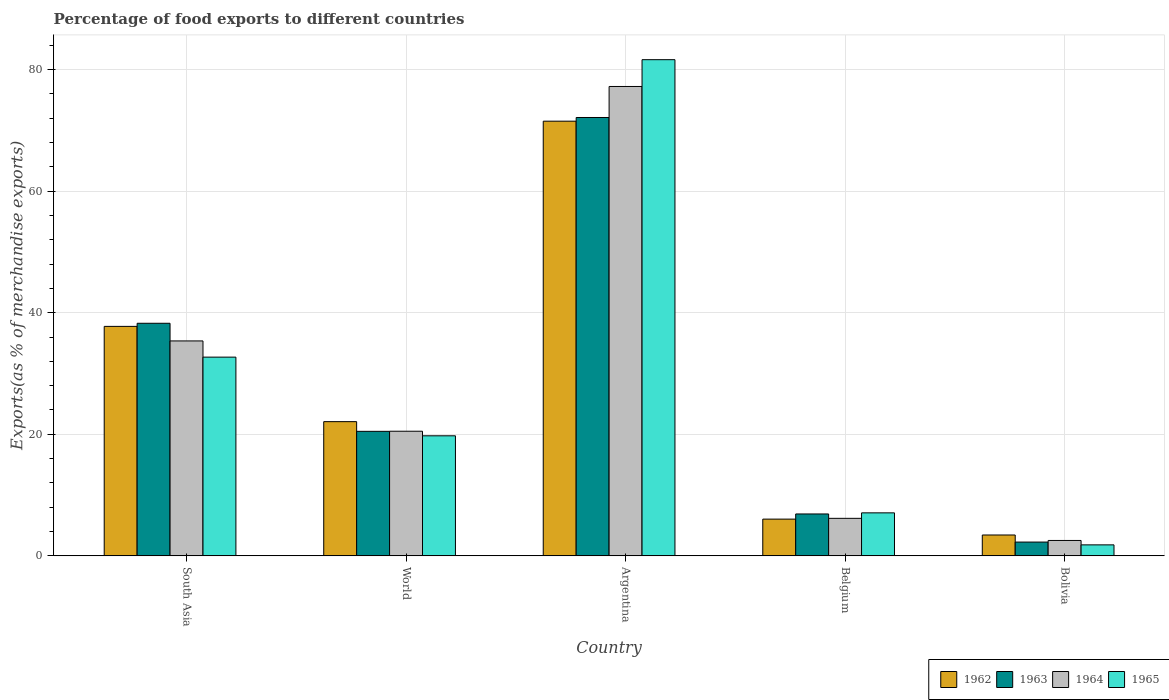Are the number of bars per tick equal to the number of legend labels?
Give a very brief answer. Yes. How many bars are there on the 4th tick from the left?
Ensure brevity in your answer.  4. How many bars are there on the 2nd tick from the right?
Your answer should be compact. 4. In how many cases, is the number of bars for a given country not equal to the number of legend labels?
Offer a terse response. 0. What is the percentage of exports to different countries in 1962 in Bolivia?
Ensure brevity in your answer.  3.43. Across all countries, what is the maximum percentage of exports to different countries in 1965?
Offer a terse response. 81.64. Across all countries, what is the minimum percentage of exports to different countries in 1964?
Offer a very short reply. 2.53. In which country was the percentage of exports to different countries in 1964 maximum?
Ensure brevity in your answer.  Argentina. What is the total percentage of exports to different countries in 1963 in the graph?
Your answer should be very brief. 140.03. What is the difference between the percentage of exports to different countries in 1963 in South Asia and that in World?
Make the answer very short. 17.78. What is the difference between the percentage of exports to different countries in 1962 in South Asia and the percentage of exports to different countries in 1965 in Argentina?
Offer a terse response. -43.88. What is the average percentage of exports to different countries in 1965 per country?
Provide a succinct answer. 28.59. What is the difference between the percentage of exports to different countries of/in 1965 and percentage of exports to different countries of/in 1964 in Bolivia?
Give a very brief answer. -0.73. What is the ratio of the percentage of exports to different countries in 1962 in Argentina to that in Bolivia?
Your answer should be very brief. 20.86. What is the difference between the highest and the second highest percentage of exports to different countries in 1965?
Your response must be concise. -48.94. What is the difference between the highest and the lowest percentage of exports to different countries in 1962?
Your answer should be very brief. 68.09. In how many countries, is the percentage of exports to different countries in 1963 greater than the average percentage of exports to different countries in 1963 taken over all countries?
Your response must be concise. 2. What does the 3rd bar from the right in South Asia represents?
Ensure brevity in your answer.  1963. Is it the case that in every country, the sum of the percentage of exports to different countries in 1964 and percentage of exports to different countries in 1963 is greater than the percentage of exports to different countries in 1962?
Your response must be concise. Yes. Are all the bars in the graph horizontal?
Your answer should be very brief. No. How many countries are there in the graph?
Your answer should be very brief. 5. Where does the legend appear in the graph?
Make the answer very short. Bottom right. How are the legend labels stacked?
Keep it short and to the point. Horizontal. What is the title of the graph?
Keep it short and to the point. Percentage of food exports to different countries. What is the label or title of the Y-axis?
Your response must be concise. Exports(as % of merchandise exports). What is the Exports(as % of merchandise exports) in 1962 in South Asia?
Your answer should be very brief. 37.75. What is the Exports(as % of merchandise exports) in 1963 in South Asia?
Your answer should be compact. 38.26. What is the Exports(as % of merchandise exports) of 1964 in South Asia?
Your answer should be very brief. 35.36. What is the Exports(as % of merchandise exports) of 1965 in South Asia?
Your response must be concise. 32.7. What is the Exports(as % of merchandise exports) in 1962 in World?
Ensure brevity in your answer.  22.08. What is the Exports(as % of merchandise exports) of 1963 in World?
Make the answer very short. 20.49. What is the Exports(as % of merchandise exports) of 1964 in World?
Keep it short and to the point. 20.5. What is the Exports(as % of merchandise exports) in 1965 in World?
Offer a terse response. 19.75. What is the Exports(as % of merchandise exports) in 1962 in Argentina?
Your answer should be very brief. 71.52. What is the Exports(as % of merchandise exports) of 1963 in Argentina?
Give a very brief answer. 72.12. What is the Exports(as % of merchandise exports) in 1964 in Argentina?
Your answer should be compact. 77.23. What is the Exports(as % of merchandise exports) of 1965 in Argentina?
Your answer should be compact. 81.64. What is the Exports(as % of merchandise exports) of 1962 in Belgium?
Give a very brief answer. 6.04. What is the Exports(as % of merchandise exports) of 1963 in Belgium?
Provide a succinct answer. 6.89. What is the Exports(as % of merchandise exports) of 1964 in Belgium?
Your answer should be compact. 6.17. What is the Exports(as % of merchandise exports) in 1965 in Belgium?
Your response must be concise. 7.07. What is the Exports(as % of merchandise exports) in 1962 in Bolivia?
Provide a succinct answer. 3.43. What is the Exports(as % of merchandise exports) of 1963 in Bolivia?
Offer a terse response. 2.27. What is the Exports(as % of merchandise exports) in 1964 in Bolivia?
Your answer should be very brief. 2.53. What is the Exports(as % of merchandise exports) of 1965 in Bolivia?
Offer a terse response. 1.81. Across all countries, what is the maximum Exports(as % of merchandise exports) in 1962?
Keep it short and to the point. 71.52. Across all countries, what is the maximum Exports(as % of merchandise exports) of 1963?
Make the answer very short. 72.12. Across all countries, what is the maximum Exports(as % of merchandise exports) in 1964?
Provide a short and direct response. 77.23. Across all countries, what is the maximum Exports(as % of merchandise exports) of 1965?
Your answer should be very brief. 81.64. Across all countries, what is the minimum Exports(as % of merchandise exports) in 1962?
Offer a terse response. 3.43. Across all countries, what is the minimum Exports(as % of merchandise exports) in 1963?
Make the answer very short. 2.27. Across all countries, what is the minimum Exports(as % of merchandise exports) in 1964?
Provide a short and direct response. 2.53. Across all countries, what is the minimum Exports(as % of merchandise exports) in 1965?
Offer a terse response. 1.81. What is the total Exports(as % of merchandise exports) of 1962 in the graph?
Keep it short and to the point. 140.82. What is the total Exports(as % of merchandise exports) in 1963 in the graph?
Ensure brevity in your answer.  140.03. What is the total Exports(as % of merchandise exports) of 1964 in the graph?
Your answer should be very brief. 141.79. What is the total Exports(as % of merchandise exports) in 1965 in the graph?
Offer a very short reply. 142.96. What is the difference between the Exports(as % of merchandise exports) of 1962 in South Asia and that in World?
Your answer should be very brief. 15.67. What is the difference between the Exports(as % of merchandise exports) of 1963 in South Asia and that in World?
Ensure brevity in your answer.  17.78. What is the difference between the Exports(as % of merchandise exports) in 1964 in South Asia and that in World?
Ensure brevity in your answer.  14.86. What is the difference between the Exports(as % of merchandise exports) in 1965 in South Asia and that in World?
Provide a succinct answer. 12.95. What is the difference between the Exports(as % of merchandise exports) of 1962 in South Asia and that in Argentina?
Offer a terse response. -33.76. What is the difference between the Exports(as % of merchandise exports) in 1963 in South Asia and that in Argentina?
Give a very brief answer. -33.86. What is the difference between the Exports(as % of merchandise exports) in 1964 in South Asia and that in Argentina?
Your response must be concise. -41.87. What is the difference between the Exports(as % of merchandise exports) in 1965 in South Asia and that in Argentina?
Keep it short and to the point. -48.94. What is the difference between the Exports(as % of merchandise exports) in 1962 in South Asia and that in Belgium?
Provide a succinct answer. 31.71. What is the difference between the Exports(as % of merchandise exports) in 1963 in South Asia and that in Belgium?
Offer a terse response. 31.37. What is the difference between the Exports(as % of merchandise exports) of 1964 in South Asia and that in Belgium?
Offer a terse response. 29.19. What is the difference between the Exports(as % of merchandise exports) of 1965 in South Asia and that in Belgium?
Give a very brief answer. 25.62. What is the difference between the Exports(as % of merchandise exports) in 1962 in South Asia and that in Bolivia?
Provide a succinct answer. 34.32. What is the difference between the Exports(as % of merchandise exports) in 1963 in South Asia and that in Bolivia?
Offer a very short reply. 36. What is the difference between the Exports(as % of merchandise exports) in 1964 in South Asia and that in Bolivia?
Your answer should be very brief. 32.83. What is the difference between the Exports(as % of merchandise exports) in 1965 in South Asia and that in Bolivia?
Your answer should be very brief. 30.89. What is the difference between the Exports(as % of merchandise exports) in 1962 in World and that in Argentina?
Provide a short and direct response. -49.44. What is the difference between the Exports(as % of merchandise exports) in 1963 in World and that in Argentina?
Offer a very short reply. -51.64. What is the difference between the Exports(as % of merchandise exports) of 1964 in World and that in Argentina?
Keep it short and to the point. -56.72. What is the difference between the Exports(as % of merchandise exports) of 1965 in World and that in Argentina?
Your answer should be very brief. -61.88. What is the difference between the Exports(as % of merchandise exports) in 1962 in World and that in Belgium?
Provide a succinct answer. 16.04. What is the difference between the Exports(as % of merchandise exports) of 1963 in World and that in Belgium?
Provide a succinct answer. 13.6. What is the difference between the Exports(as % of merchandise exports) in 1964 in World and that in Belgium?
Make the answer very short. 14.33. What is the difference between the Exports(as % of merchandise exports) in 1965 in World and that in Belgium?
Offer a very short reply. 12.68. What is the difference between the Exports(as % of merchandise exports) in 1962 in World and that in Bolivia?
Make the answer very short. 18.65. What is the difference between the Exports(as % of merchandise exports) of 1963 in World and that in Bolivia?
Provide a short and direct response. 18.22. What is the difference between the Exports(as % of merchandise exports) of 1964 in World and that in Bolivia?
Give a very brief answer. 17.97. What is the difference between the Exports(as % of merchandise exports) in 1965 in World and that in Bolivia?
Your answer should be compact. 17.94. What is the difference between the Exports(as % of merchandise exports) in 1962 in Argentina and that in Belgium?
Make the answer very short. 65.47. What is the difference between the Exports(as % of merchandise exports) of 1963 in Argentina and that in Belgium?
Provide a short and direct response. 65.23. What is the difference between the Exports(as % of merchandise exports) of 1964 in Argentina and that in Belgium?
Your response must be concise. 71.06. What is the difference between the Exports(as % of merchandise exports) in 1965 in Argentina and that in Belgium?
Your answer should be very brief. 74.56. What is the difference between the Exports(as % of merchandise exports) in 1962 in Argentina and that in Bolivia?
Ensure brevity in your answer.  68.09. What is the difference between the Exports(as % of merchandise exports) of 1963 in Argentina and that in Bolivia?
Make the answer very short. 69.86. What is the difference between the Exports(as % of merchandise exports) of 1964 in Argentina and that in Bolivia?
Your answer should be compact. 74.69. What is the difference between the Exports(as % of merchandise exports) in 1965 in Argentina and that in Bolivia?
Ensure brevity in your answer.  79.83. What is the difference between the Exports(as % of merchandise exports) in 1962 in Belgium and that in Bolivia?
Make the answer very short. 2.61. What is the difference between the Exports(as % of merchandise exports) in 1963 in Belgium and that in Bolivia?
Your response must be concise. 4.62. What is the difference between the Exports(as % of merchandise exports) of 1964 in Belgium and that in Bolivia?
Provide a short and direct response. 3.64. What is the difference between the Exports(as % of merchandise exports) of 1965 in Belgium and that in Bolivia?
Provide a succinct answer. 5.27. What is the difference between the Exports(as % of merchandise exports) in 1962 in South Asia and the Exports(as % of merchandise exports) in 1963 in World?
Offer a terse response. 17.27. What is the difference between the Exports(as % of merchandise exports) in 1962 in South Asia and the Exports(as % of merchandise exports) in 1964 in World?
Provide a short and direct response. 17.25. What is the difference between the Exports(as % of merchandise exports) in 1962 in South Asia and the Exports(as % of merchandise exports) in 1965 in World?
Ensure brevity in your answer.  18. What is the difference between the Exports(as % of merchandise exports) of 1963 in South Asia and the Exports(as % of merchandise exports) of 1964 in World?
Keep it short and to the point. 17.76. What is the difference between the Exports(as % of merchandise exports) in 1963 in South Asia and the Exports(as % of merchandise exports) in 1965 in World?
Your response must be concise. 18.51. What is the difference between the Exports(as % of merchandise exports) in 1964 in South Asia and the Exports(as % of merchandise exports) in 1965 in World?
Give a very brief answer. 15.61. What is the difference between the Exports(as % of merchandise exports) of 1962 in South Asia and the Exports(as % of merchandise exports) of 1963 in Argentina?
Offer a very short reply. -34.37. What is the difference between the Exports(as % of merchandise exports) in 1962 in South Asia and the Exports(as % of merchandise exports) in 1964 in Argentina?
Ensure brevity in your answer.  -39.47. What is the difference between the Exports(as % of merchandise exports) in 1962 in South Asia and the Exports(as % of merchandise exports) in 1965 in Argentina?
Your response must be concise. -43.88. What is the difference between the Exports(as % of merchandise exports) of 1963 in South Asia and the Exports(as % of merchandise exports) of 1964 in Argentina?
Make the answer very short. -38.96. What is the difference between the Exports(as % of merchandise exports) of 1963 in South Asia and the Exports(as % of merchandise exports) of 1965 in Argentina?
Provide a short and direct response. -43.37. What is the difference between the Exports(as % of merchandise exports) of 1964 in South Asia and the Exports(as % of merchandise exports) of 1965 in Argentina?
Your answer should be compact. -46.28. What is the difference between the Exports(as % of merchandise exports) of 1962 in South Asia and the Exports(as % of merchandise exports) of 1963 in Belgium?
Provide a short and direct response. 30.86. What is the difference between the Exports(as % of merchandise exports) in 1962 in South Asia and the Exports(as % of merchandise exports) in 1964 in Belgium?
Your answer should be very brief. 31.58. What is the difference between the Exports(as % of merchandise exports) in 1962 in South Asia and the Exports(as % of merchandise exports) in 1965 in Belgium?
Provide a succinct answer. 30.68. What is the difference between the Exports(as % of merchandise exports) in 1963 in South Asia and the Exports(as % of merchandise exports) in 1964 in Belgium?
Offer a very short reply. 32.09. What is the difference between the Exports(as % of merchandise exports) in 1963 in South Asia and the Exports(as % of merchandise exports) in 1965 in Belgium?
Your answer should be very brief. 31.19. What is the difference between the Exports(as % of merchandise exports) in 1964 in South Asia and the Exports(as % of merchandise exports) in 1965 in Belgium?
Offer a terse response. 28.29. What is the difference between the Exports(as % of merchandise exports) of 1962 in South Asia and the Exports(as % of merchandise exports) of 1963 in Bolivia?
Offer a terse response. 35.49. What is the difference between the Exports(as % of merchandise exports) in 1962 in South Asia and the Exports(as % of merchandise exports) in 1964 in Bolivia?
Offer a very short reply. 35.22. What is the difference between the Exports(as % of merchandise exports) in 1962 in South Asia and the Exports(as % of merchandise exports) in 1965 in Bolivia?
Ensure brevity in your answer.  35.95. What is the difference between the Exports(as % of merchandise exports) of 1963 in South Asia and the Exports(as % of merchandise exports) of 1964 in Bolivia?
Provide a succinct answer. 35.73. What is the difference between the Exports(as % of merchandise exports) of 1963 in South Asia and the Exports(as % of merchandise exports) of 1965 in Bolivia?
Keep it short and to the point. 36.46. What is the difference between the Exports(as % of merchandise exports) in 1964 in South Asia and the Exports(as % of merchandise exports) in 1965 in Bolivia?
Give a very brief answer. 33.55. What is the difference between the Exports(as % of merchandise exports) of 1962 in World and the Exports(as % of merchandise exports) of 1963 in Argentina?
Your answer should be very brief. -50.04. What is the difference between the Exports(as % of merchandise exports) in 1962 in World and the Exports(as % of merchandise exports) in 1964 in Argentina?
Give a very brief answer. -55.15. What is the difference between the Exports(as % of merchandise exports) in 1962 in World and the Exports(as % of merchandise exports) in 1965 in Argentina?
Keep it short and to the point. -59.55. What is the difference between the Exports(as % of merchandise exports) of 1963 in World and the Exports(as % of merchandise exports) of 1964 in Argentina?
Offer a terse response. -56.74. What is the difference between the Exports(as % of merchandise exports) of 1963 in World and the Exports(as % of merchandise exports) of 1965 in Argentina?
Your answer should be compact. -61.15. What is the difference between the Exports(as % of merchandise exports) in 1964 in World and the Exports(as % of merchandise exports) in 1965 in Argentina?
Provide a short and direct response. -61.13. What is the difference between the Exports(as % of merchandise exports) in 1962 in World and the Exports(as % of merchandise exports) in 1963 in Belgium?
Your answer should be very brief. 15.19. What is the difference between the Exports(as % of merchandise exports) in 1962 in World and the Exports(as % of merchandise exports) in 1964 in Belgium?
Provide a short and direct response. 15.91. What is the difference between the Exports(as % of merchandise exports) in 1962 in World and the Exports(as % of merchandise exports) in 1965 in Belgium?
Make the answer very short. 15.01. What is the difference between the Exports(as % of merchandise exports) of 1963 in World and the Exports(as % of merchandise exports) of 1964 in Belgium?
Give a very brief answer. 14.32. What is the difference between the Exports(as % of merchandise exports) of 1963 in World and the Exports(as % of merchandise exports) of 1965 in Belgium?
Make the answer very short. 13.41. What is the difference between the Exports(as % of merchandise exports) in 1964 in World and the Exports(as % of merchandise exports) in 1965 in Belgium?
Offer a terse response. 13.43. What is the difference between the Exports(as % of merchandise exports) of 1962 in World and the Exports(as % of merchandise exports) of 1963 in Bolivia?
Provide a short and direct response. 19.81. What is the difference between the Exports(as % of merchandise exports) in 1962 in World and the Exports(as % of merchandise exports) in 1964 in Bolivia?
Offer a very short reply. 19.55. What is the difference between the Exports(as % of merchandise exports) of 1962 in World and the Exports(as % of merchandise exports) of 1965 in Bolivia?
Ensure brevity in your answer.  20.27. What is the difference between the Exports(as % of merchandise exports) in 1963 in World and the Exports(as % of merchandise exports) in 1964 in Bolivia?
Ensure brevity in your answer.  17.95. What is the difference between the Exports(as % of merchandise exports) in 1963 in World and the Exports(as % of merchandise exports) in 1965 in Bolivia?
Your response must be concise. 18.68. What is the difference between the Exports(as % of merchandise exports) in 1964 in World and the Exports(as % of merchandise exports) in 1965 in Bolivia?
Your response must be concise. 18.7. What is the difference between the Exports(as % of merchandise exports) in 1962 in Argentina and the Exports(as % of merchandise exports) in 1963 in Belgium?
Ensure brevity in your answer.  64.63. What is the difference between the Exports(as % of merchandise exports) in 1962 in Argentina and the Exports(as % of merchandise exports) in 1964 in Belgium?
Your response must be concise. 65.35. What is the difference between the Exports(as % of merchandise exports) of 1962 in Argentina and the Exports(as % of merchandise exports) of 1965 in Belgium?
Offer a terse response. 64.44. What is the difference between the Exports(as % of merchandise exports) of 1963 in Argentina and the Exports(as % of merchandise exports) of 1964 in Belgium?
Ensure brevity in your answer.  65.95. What is the difference between the Exports(as % of merchandise exports) of 1963 in Argentina and the Exports(as % of merchandise exports) of 1965 in Belgium?
Give a very brief answer. 65.05. What is the difference between the Exports(as % of merchandise exports) of 1964 in Argentina and the Exports(as % of merchandise exports) of 1965 in Belgium?
Your answer should be compact. 70.15. What is the difference between the Exports(as % of merchandise exports) in 1962 in Argentina and the Exports(as % of merchandise exports) in 1963 in Bolivia?
Ensure brevity in your answer.  69.25. What is the difference between the Exports(as % of merchandise exports) in 1962 in Argentina and the Exports(as % of merchandise exports) in 1964 in Bolivia?
Make the answer very short. 68.98. What is the difference between the Exports(as % of merchandise exports) in 1962 in Argentina and the Exports(as % of merchandise exports) in 1965 in Bolivia?
Your answer should be compact. 69.71. What is the difference between the Exports(as % of merchandise exports) of 1963 in Argentina and the Exports(as % of merchandise exports) of 1964 in Bolivia?
Provide a succinct answer. 69.59. What is the difference between the Exports(as % of merchandise exports) of 1963 in Argentina and the Exports(as % of merchandise exports) of 1965 in Bolivia?
Keep it short and to the point. 70.32. What is the difference between the Exports(as % of merchandise exports) in 1964 in Argentina and the Exports(as % of merchandise exports) in 1965 in Bolivia?
Provide a short and direct response. 75.42. What is the difference between the Exports(as % of merchandise exports) of 1962 in Belgium and the Exports(as % of merchandise exports) of 1963 in Bolivia?
Your response must be concise. 3.78. What is the difference between the Exports(as % of merchandise exports) in 1962 in Belgium and the Exports(as % of merchandise exports) in 1964 in Bolivia?
Your answer should be compact. 3.51. What is the difference between the Exports(as % of merchandise exports) in 1962 in Belgium and the Exports(as % of merchandise exports) in 1965 in Bolivia?
Keep it short and to the point. 4.24. What is the difference between the Exports(as % of merchandise exports) of 1963 in Belgium and the Exports(as % of merchandise exports) of 1964 in Bolivia?
Provide a short and direct response. 4.36. What is the difference between the Exports(as % of merchandise exports) of 1963 in Belgium and the Exports(as % of merchandise exports) of 1965 in Bolivia?
Offer a very short reply. 5.08. What is the difference between the Exports(as % of merchandise exports) in 1964 in Belgium and the Exports(as % of merchandise exports) in 1965 in Bolivia?
Offer a very short reply. 4.36. What is the average Exports(as % of merchandise exports) of 1962 per country?
Keep it short and to the point. 28.16. What is the average Exports(as % of merchandise exports) of 1963 per country?
Your answer should be compact. 28.01. What is the average Exports(as % of merchandise exports) in 1964 per country?
Provide a short and direct response. 28.36. What is the average Exports(as % of merchandise exports) in 1965 per country?
Keep it short and to the point. 28.59. What is the difference between the Exports(as % of merchandise exports) in 1962 and Exports(as % of merchandise exports) in 1963 in South Asia?
Offer a terse response. -0.51. What is the difference between the Exports(as % of merchandise exports) in 1962 and Exports(as % of merchandise exports) in 1964 in South Asia?
Make the answer very short. 2.39. What is the difference between the Exports(as % of merchandise exports) in 1962 and Exports(as % of merchandise exports) in 1965 in South Asia?
Offer a very short reply. 5.06. What is the difference between the Exports(as % of merchandise exports) in 1963 and Exports(as % of merchandise exports) in 1964 in South Asia?
Provide a short and direct response. 2.9. What is the difference between the Exports(as % of merchandise exports) of 1963 and Exports(as % of merchandise exports) of 1965 in South Asia?
Your response must be concise. 5.57. What is the difference between the Exports(as % of merchandise exports) in 1964 and Exports(as % of merchandise exports) in 1965 in South Asia?
Offer a very short reply. 2.66. What is the difference between the Exports(as % of merchandise exports) of 1962 and Exports(as % of merchandise exports) of 1963 in World?
Your response must be concise. 1.59. What is the difference between the Exports(as % of merchandise exports) in 1962 and Exports(as % of merchandise exports) in 1964 in World?
Your answer should be compact. 1.58. What is the difference between the Exports(as % of merchandise exports) of 1962 and Exports(as % of merchandise exports) of 1965 in World?
Your answer should be compact. 2.33. What is the difference between the Exports(as % of merchandise exports) of 1963 and Exports(as % of merchandise exports) of 1964 in World?
Your response must be concise. -0.02. What is the difference between the Exports(as % of merchandise exports) of 1963 and Exports(as % of merchandise exports) of 1965 in World?
Give a very brief answer. 0.74. What is the difference between the Exports(as % of merchandise exports) in 1964 and Exports(as % of merchandise exports) in 1965 in World?
Offer a very short reply. 0.75. What is the difference between the Exports(as % of merchandise exports) in 1962 and Exports(as % of merchandise exports) in 1963 in Argentina?
Provide a succinct answer. -0.61. What is the difference between the Exports(as % of merchandise exports) in 1962 and Exports(as % of merchandise exports) in 1964 in Argentina?
Your answer should be compact. -5.71. What is the difference between the Exports(as % of merchandise exports) in 1962 and Exports(as % of merchandise exports) in 1965 in Argentina?
Give a very brief answer. -10.12. What is the difference between the Exports(as % of merchandise exports) of 1963 and Exports(as % of merchandise exports) of 1964 in Argentina?
Give a very brief answer. -5.1. What is the difference between the Exports(as % of merchandise exports) in 1963 and Exports(as % of merchandise exports) in 1965 in Argentina?
Provide a short and direct response. -9.51. What is the difference between the Exports(as % of merchandise exports) of 1964 and Exports(as % of merchandise exports) of 1965 in Argentina?
Make the answer very short. -4.41. What is the difference between the Exports(as % of merchandise exports) of 1962 and Exports(as % of merchandise exports) of 1963 in Belgium?
Offer a very short reply. -0.85. What is the difference between the Exports(as % of merchandise exports) of 1962 and Exports(as % of merchandise exports) of 1964 in Belgium?
Keep it short and to the point. -0.13. What is the difference between the Exports(as % of merchandise exports) in 1962 and Exports(as % of merchandise exports) in 1965 in Belgium?
Provide a short and direct response. -1.03. What is the difference between the Exports(as % of merchandise exports) of 1963 and Exports(as % of merchandise exports) of 1964 in Belgium?
Offer a very short reply. 0.72. What is the difference between the Exports(as % of merchandise exports) of 1963 and Exports(as % of merchandise exports) of 1965 in Belgium?
Make the answer very short. -0.18. What is the difference between the Exports(as % of merchandise exports) of 1964 and Exports(as % of merchandise exports) of 1965 in Belgium?
Make the answer very short. -0.9. What is the difference between the Exports(as % of merchandise exports) of 1962 and Exports(as % of merchandise exports) of 1963 in Bolivia?
Your response must be concise. 1.16. What is the difference between the Exports(as % of merchandise exports) of 1962 and Exports(as % of merchandise exports) of 1964 in Bolivia?
Your answer should be very brief. 0.9. What is the difference between the Exports(as % of merchandise exports) in 1962 and Exports(as % of merchandise exports) in 1965 in Bolivia?
Provide a short and direct response. 1.62. What is the difference between the Exports(as % of merchandise exports) of 1963 and Exports(as % of merchandise exports) of 1964 in Bolivia?
Provide a succinct answer. -0.27. What is the difference between the Exports(as % of merchandise exports) of 1963 and Exports(as % of merchandise exports) of 1965 in Bolivia?
Give a very brief answer. 0.46. What is the difference between the Exports(as % of merchandise exports) of 1964 and Exports(as % of merchandise exports) of 1965 in Bolivia?
Keep it short and to the point. 0.73. What is the ratio of the Exports(as % of merchandise exports) of 1962 in South Asia to that in World?
Make the answer very short. 1.71. What is the ratio of the Exports(as % of merchandise exports) in 1963 in South Asia to that in World?
Provide a short and direct response. 1.87. What is the ratio of the Exports(as % of merchandise exports) of 1964 in South Asia to that in World?
Give a very brief answer. 1.72. What is the ratio of the Exports(as % of merchandise exports) of 1965 in South Asia to that in World?
Give a very brief answer. 1.66. What is the ratio of the Exports(as % of merchandise exports) in 1962 in South Asia to that in Argentina?
Ensure brevity in your answer.  0.53. What is the ratio of the Exports(as % of merchandise exports) in 1963 in South Asia to that in Argentina?
Ensure brevity in your answer.  0.53. What is the ratio of the Exports(as % of merchandise exports) of 1964 in South Asia to that in Argentina?
Make the answer very short. 0.46. What is the ratio of the Exports(as % of merchandise exports) in 1965 in South Asia to that in Argentina?
Offer a terse response. 0.4. What is the ratio of the Exports(as % of merchandise exports) of 1962 in South Asia to that in Belgium?
Offer a terse response. 6.25. What is the ratio of the Exports(as % of merchandise exports) in 1963 in South Asia to that in Belgium?
Give a very brief answer. 5.55. What is the ratio of the Exports(as % of merchandise exports) of 1964 in South Asia to that in Belgium?
Make the answer very short. 5.73. What is the ratio of the Exports(as % of merchandise exports) in 1965 in South Asia to that in Belgium?
Give a very brief answer. 4.62. What is the ratio of the Exports(as % of merchandise exports) of 1962 in South Asia to that in Bolivia?
Your answer should be compact. 11.01. What is the ratio of the Exports(as % of merchandise exports) in 1963 in South Asia to that in Bolivia?
Offer a very short reply. 16.89. What is the ratio of the Exports(as % of merchandise exports) in 1964 in South Asia to that in Bolivia?
Ensure brevity in your answer.  13.97. What is the ratio of the Exports(as % of merchandise exports) in 1965 in South Asia to that in Bolivia?
Offer a terse response. 18.1. What is the ratio of the Exports(as % of merchandise exports) in 1962 in World to that in Argentina?
Make the answer very short. 0.31. What is the ratio of the Exports(as % of merchandise exports) of 1963 in World to that in Argentina?
Provide a succinct answer. 0.28. What is the ratio of the Exports(as % of merchandise exports) of 1964 in World to that in Argentina?
Your answer should be compact. 0.27. What is the ratio of the Exports(as % of merchandise exports) of 1965 in World to that in Argentina?
Your answer should be compact. 0.24. What is the ratio of the Exports(as % of merchandise exports) in 1962 in World to that in Belgium?
Your answer should be very brief. 3.65. What is the ratio of the Exports(as % of merchandise exports) in 1963 in World to that in Belgium?
Your response must be concise. 2.97. What is the ratio of the Exports(as % of merchandise exports) of 1964 in World to that in Belgium?
Give a very brief answer. 3.32. What is the ratio of the Exports(as % of merchandise exports) in 1965 in World to that in Belgium?
Offer a terse response. 2.79. What is the ratio of the Exports(as % of merchandise exports) of 1962 in World to that in Bolivia?
Your response must be concise. 6.44. What is the ratio of the Exports(as % of merchandise exports) in 1963 in World to that in Bolivia?
Give a very brief answer. 9.04. What is the ratio of the Exports(as % of merchandise exports) in 1964 in World to that in Bolivia?
Ensure brevity in your answer.  8.1. What is the ratio of the Exports(as % of merchandise exports) in 1965 in World to that in Bolivia?
Keep it short and to the point. 10.93. What is the ratio of the Exports(as % of merchandise exports) in 1962 in Argentina to that in Belgium?
Your answer should be very brief. 11.84. What is the ratio of the Exports(as % of merchandise exports) of 1963 in Argentina to that in Belgium?
Your response must be concise. 10.47. What is the ratio of the Exports(as % of merchandise exports) in 1964 in Argentina to that in Belgium?
Your answer should be very brief. 12.52. What is the ratio of the Exports(as % of merchandise exports) in 1965 in Argentina to that in Belgium?
Provide a succinct answer. 11.54. What is the ratio of the Exports(as % of merchandise exports) in 1962 in Argentina to that in Bolivia?
Ensure brevity in your answer.  20.86. What is the ratio of the Exports(as % of merchandise exports) in 1963 in Argentina to that in Bolivia?
Offer a very short reply. 31.83. What is the ratio of the Exports(as % of merchandise exports) of 1964 in Argentina to that in Bolivia?
Offer a very short reply. 30.5. What is the ratio of the Exports(as % of merchandise exports) of 1965 in Argentina to that in Bolivia?
Give a very brief answer. 45.18. What is the ratio of the Exports(as % of merchandise exports) in 1962 in Belgium to that in Bolivia?
Offer a terse response. 1.76. What is the ratio of the Exports(as % of merchandise exports) in 1963 in Belgium to that in Bolivia?
Give a very brief answer. 3.04. What is the ratio of the Exports(as % of merchandise exports) of 1964 in Belgium to that in Bolivia?
Your response must be concise. 2.44. What is the ratio of the Exports(as % of merchandise exports) in 1965 in Belgium to that in Bolivia?
Your answer should be very brief. 3.91. What is the difference between the highest and the second highest Exports(as % of merchandise exports) in 1962?
Ensure brevity in your answer.  33.76. What is the difference between the highest and the second highest Exports(as % of merchandise exports) in 1963?
Your answer should be compact. 33.86. What is the difference between the highest and the second highest Exports(as % of merchandise exports) of 1964?
Provide a succinct answer. 41.87. What is the difference between the highest and the second highest Exports(as % of merchandise exports) of 1965?
Offer a very short reply. 48.94. What is the difference between the highest and the lowest Exports(as % of merchandise exports) of 1962?
Provide a succinct answer. 68.09. What is the difference between the highest and the lowest Exports(as % of merchandise exports) in 1963?
Make the answer very short. 69.86. What is the difference between the highest and the lowest Exports(as % of merchandise exports) in 1964?
Keep it short and to the point. 74.69. What is the difference between the highest and the lowest Exports(as % of merchandise exports) in 1965?
Your answer should be very brief. 79.83. 